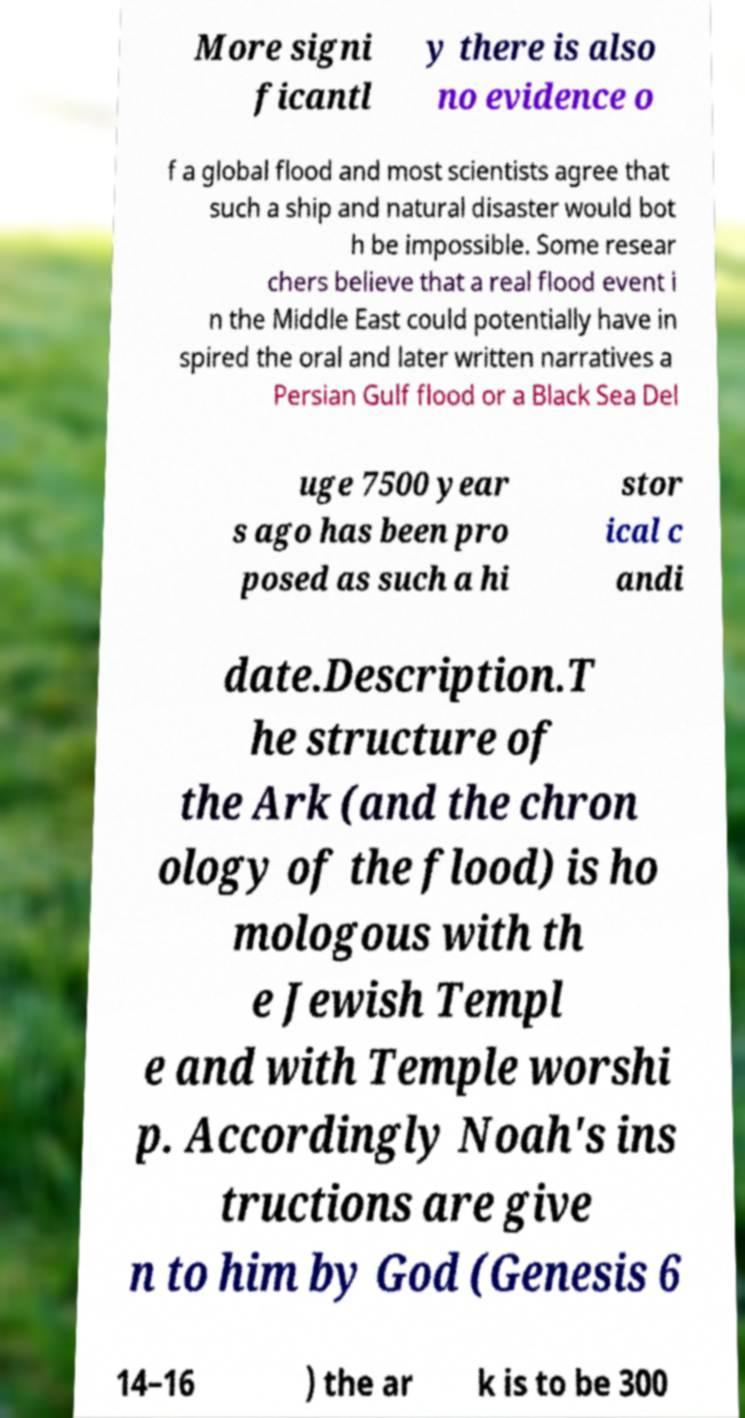Can you accurately transcribe the text from the provided image for me? More signi ficantl y there is also no evidence o f a global flood and most scientists agree that such a ship and natural disaster would bot h be impossible. Some resear chers believe that a real flood event i n the Middle East could potentially have in spired the oral and later written narratives a Persian Gulf flood or a Black Sea Del uge 7500 year s ago has been pro posed as such a hi stor ical c andi date.Description.T he structure of the Ark (and the chron ology of the flood) is ho mologous with th e Jewish Templ e and with Temple worshi p. Accordingly Noah's ins tructions are give n to him by God (Genesis 6 14–16 ) the ar k is to be 300 